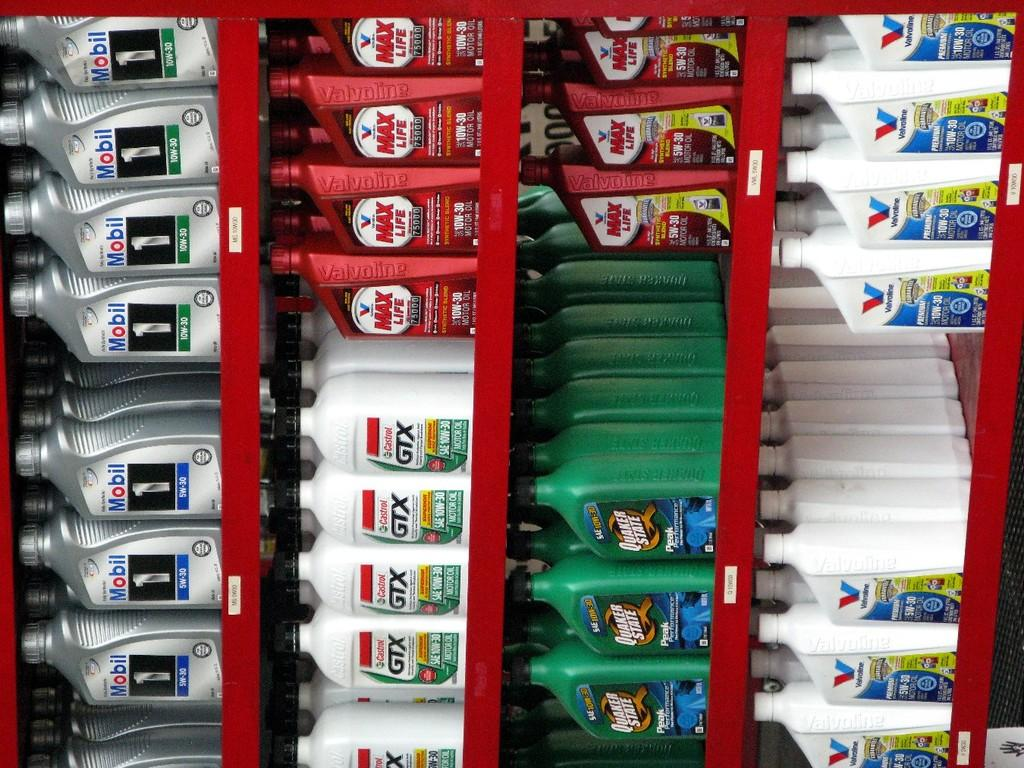<image>
Present a compact description of the photo's key features. Many different bottles of motor oil on shelves including some for the brand of Mobil. 